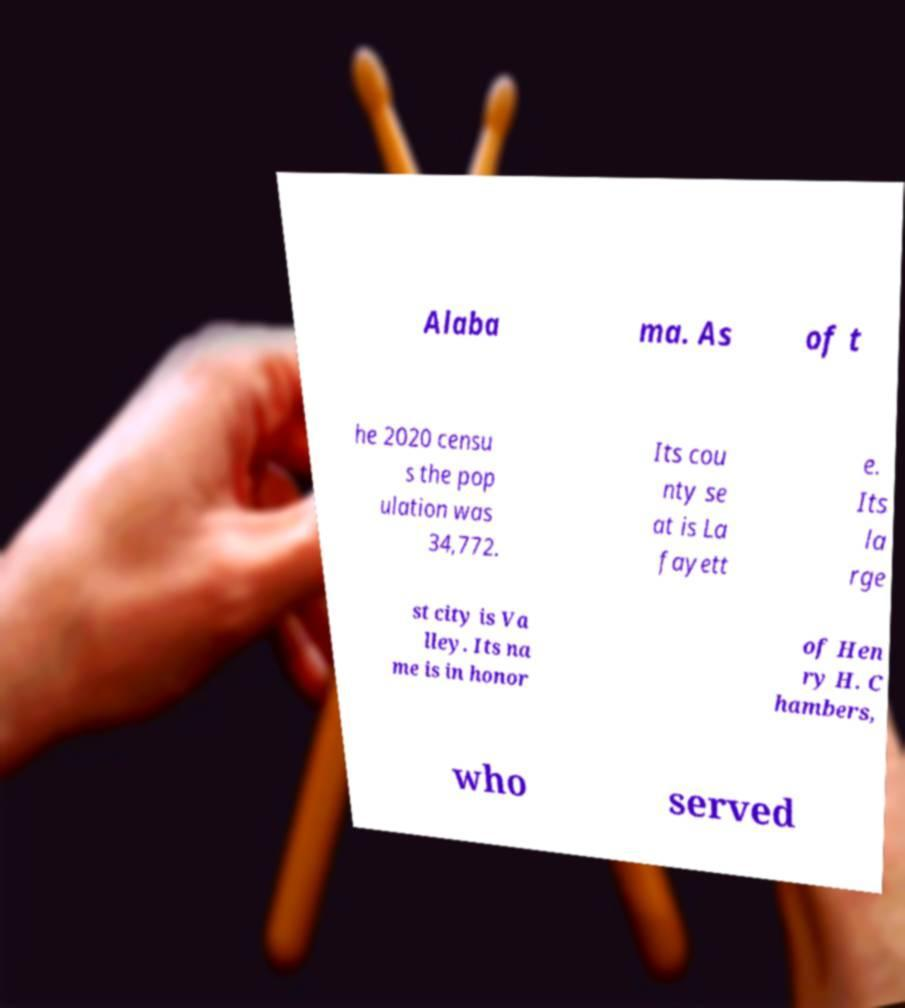Could you assist in decoding the text presented in this image and type it out clearly? Alaba ma. As of t he 2020 censu s the pop ulation was 34,772. Its cou nty se at is La fayett e. Its la rge st city is Va lley. Its na me is in honor of Hen ry H. C hambers, who served 